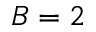<formula> <loc_0><loc_0><loc_500><loc_500>B = 2</formula> 